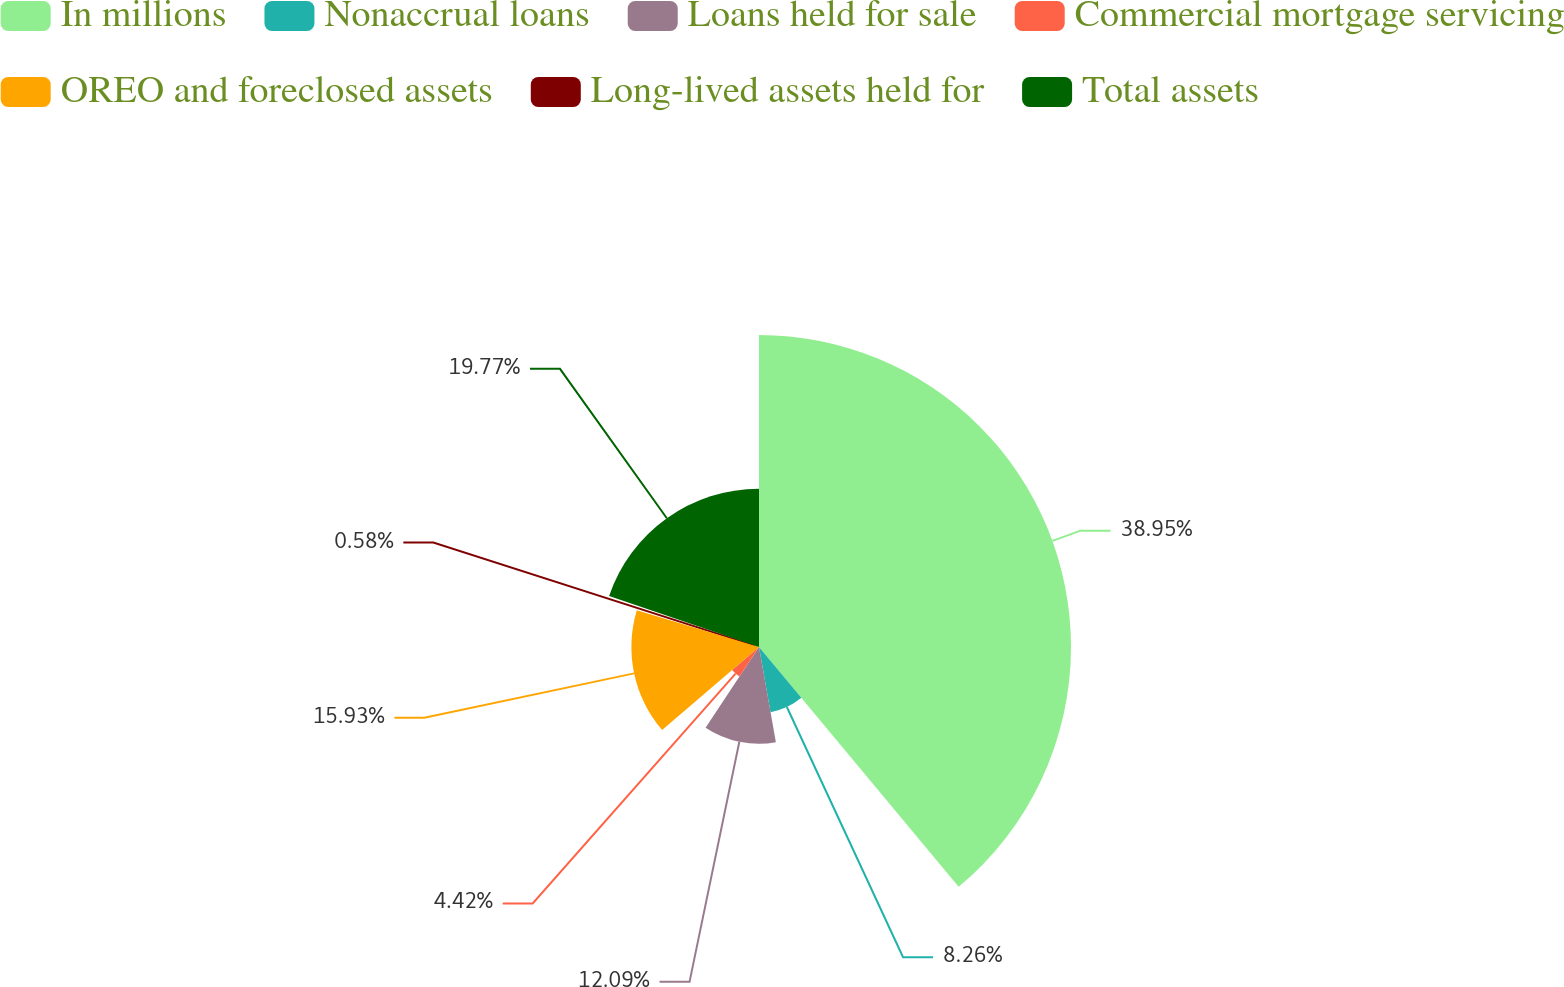Convert chart. <chart><loc_0><loc_0><loc_500><loc_500><pie_chart><fcel>In millions<fcel>Nonaccrual loans<fcel>Loans held for sale<fcel>Commercial mortgage servicing<fcel>OREO and foreclosed assets<fcel>Long-lived assets held for<fcel>Total assets<nl><fcel>38.95%<fcel>8.26%<fcel>12.09%<fcel>4.42%<fcel>15.93%<fcel>0.58%<fcel>19.77%<nl></chart> 